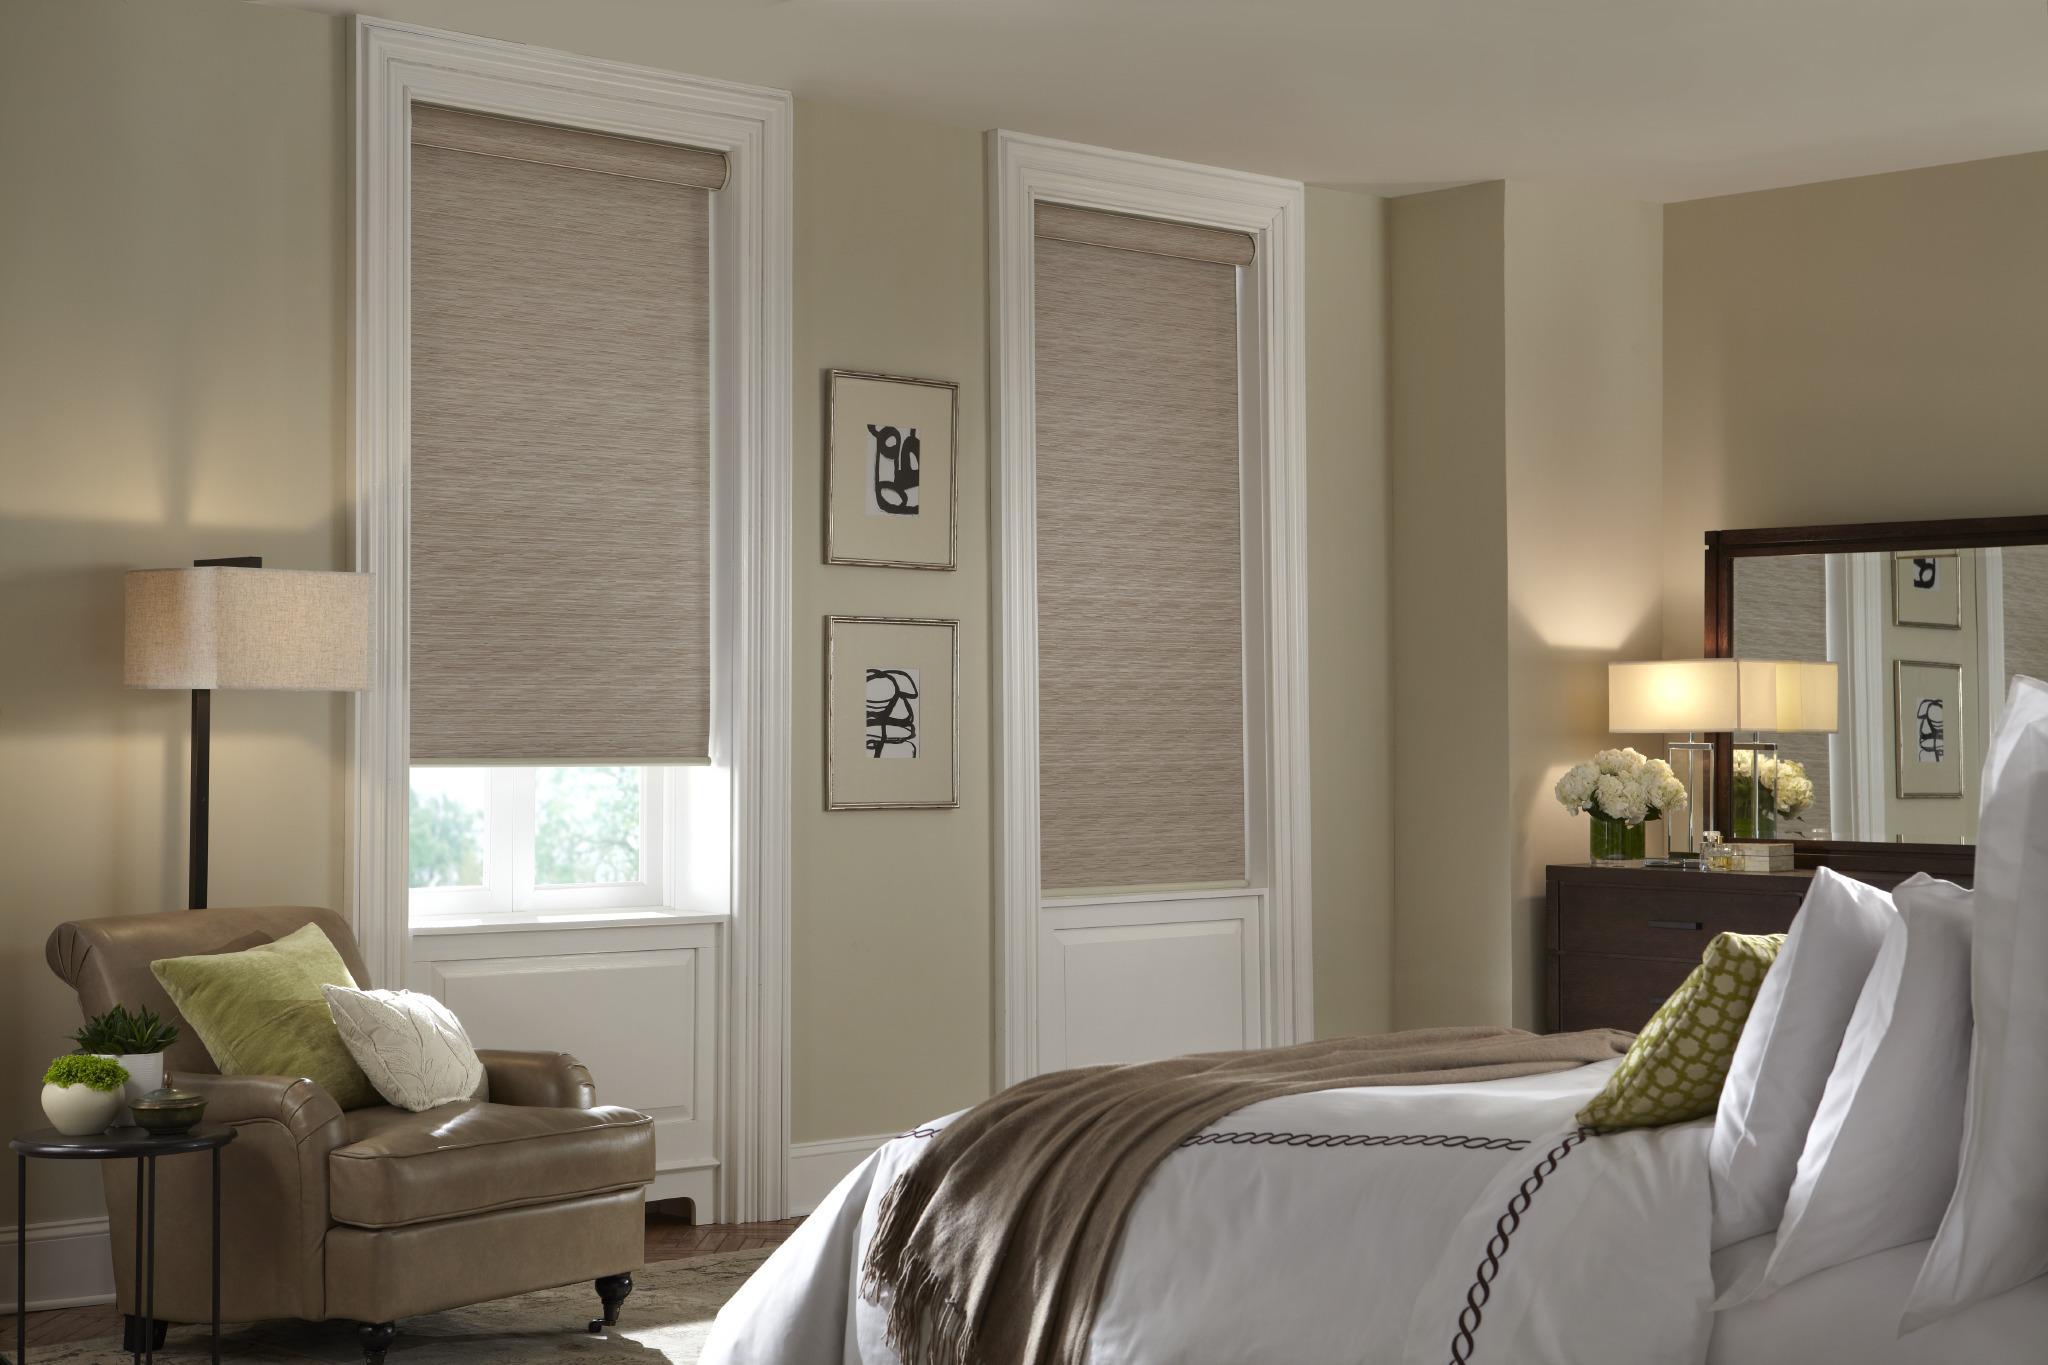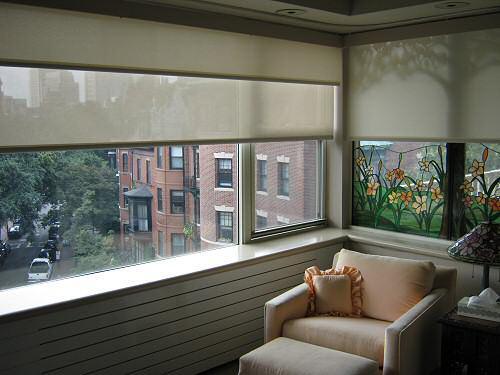The first image is the image on the left, the second image is the image on the right. Given the left and right images, does the statement "all the shades in the right image are partially open." hold true? Answer yes or no. Yes. The first image is the image on the left, the second image is the image on the right. For the images shown, is this caption "An image shows three neutral-colored shades in a row on a straight wall, each covering at least 2/3 of a pane-less window." true? Answer yes or no. No. 